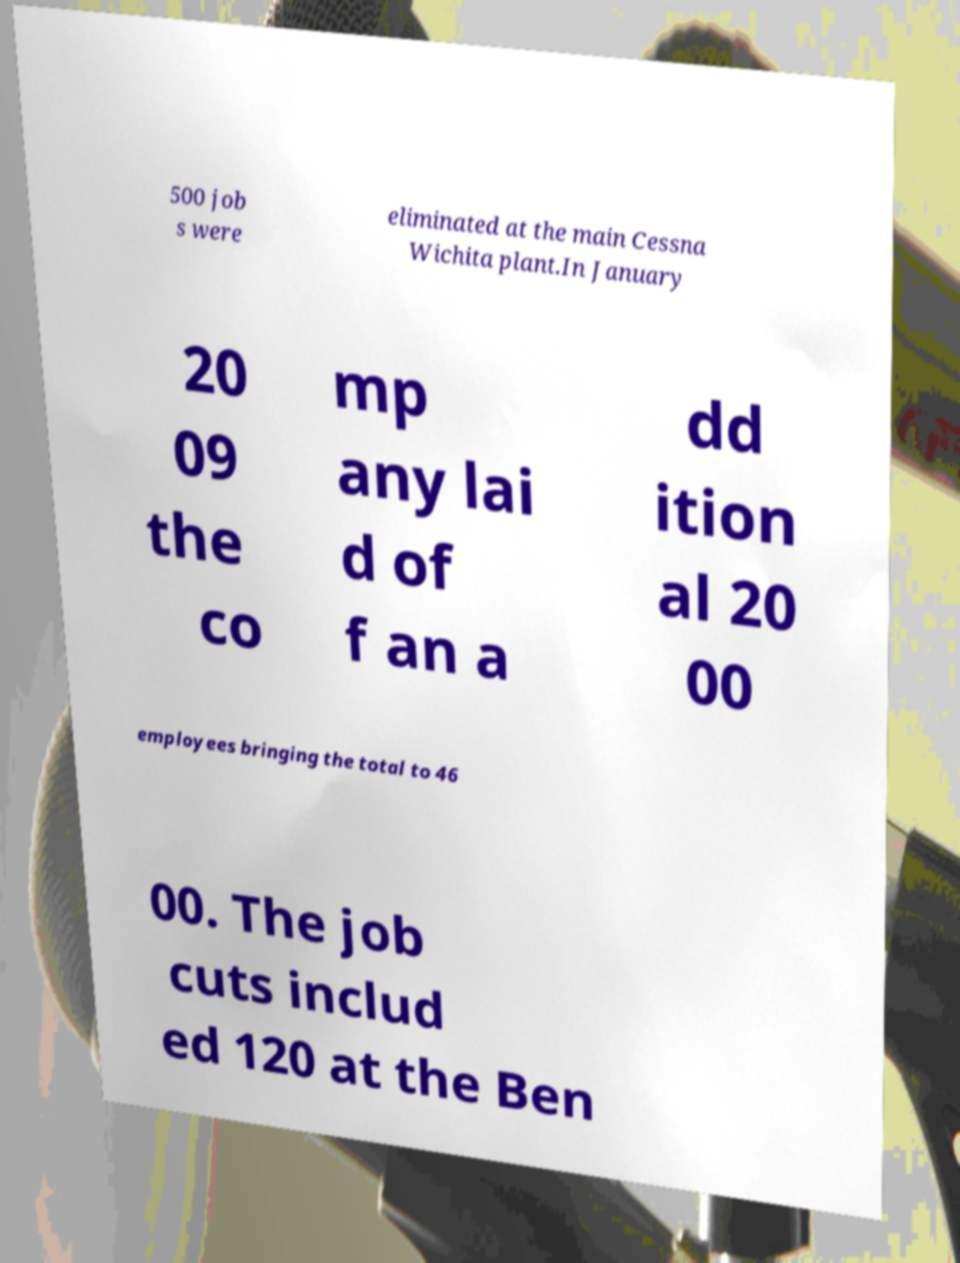For documentation purposes, I need the text within this image transcribed. Could you provide that? 500 job s were eliminated at the main Cessna Wichita plant.In January 20 09 the co mp any lai d of f an a dd ition al 20 00 employees bringing the total to 46 00. The job cuts includ ed 120 at the Ben 